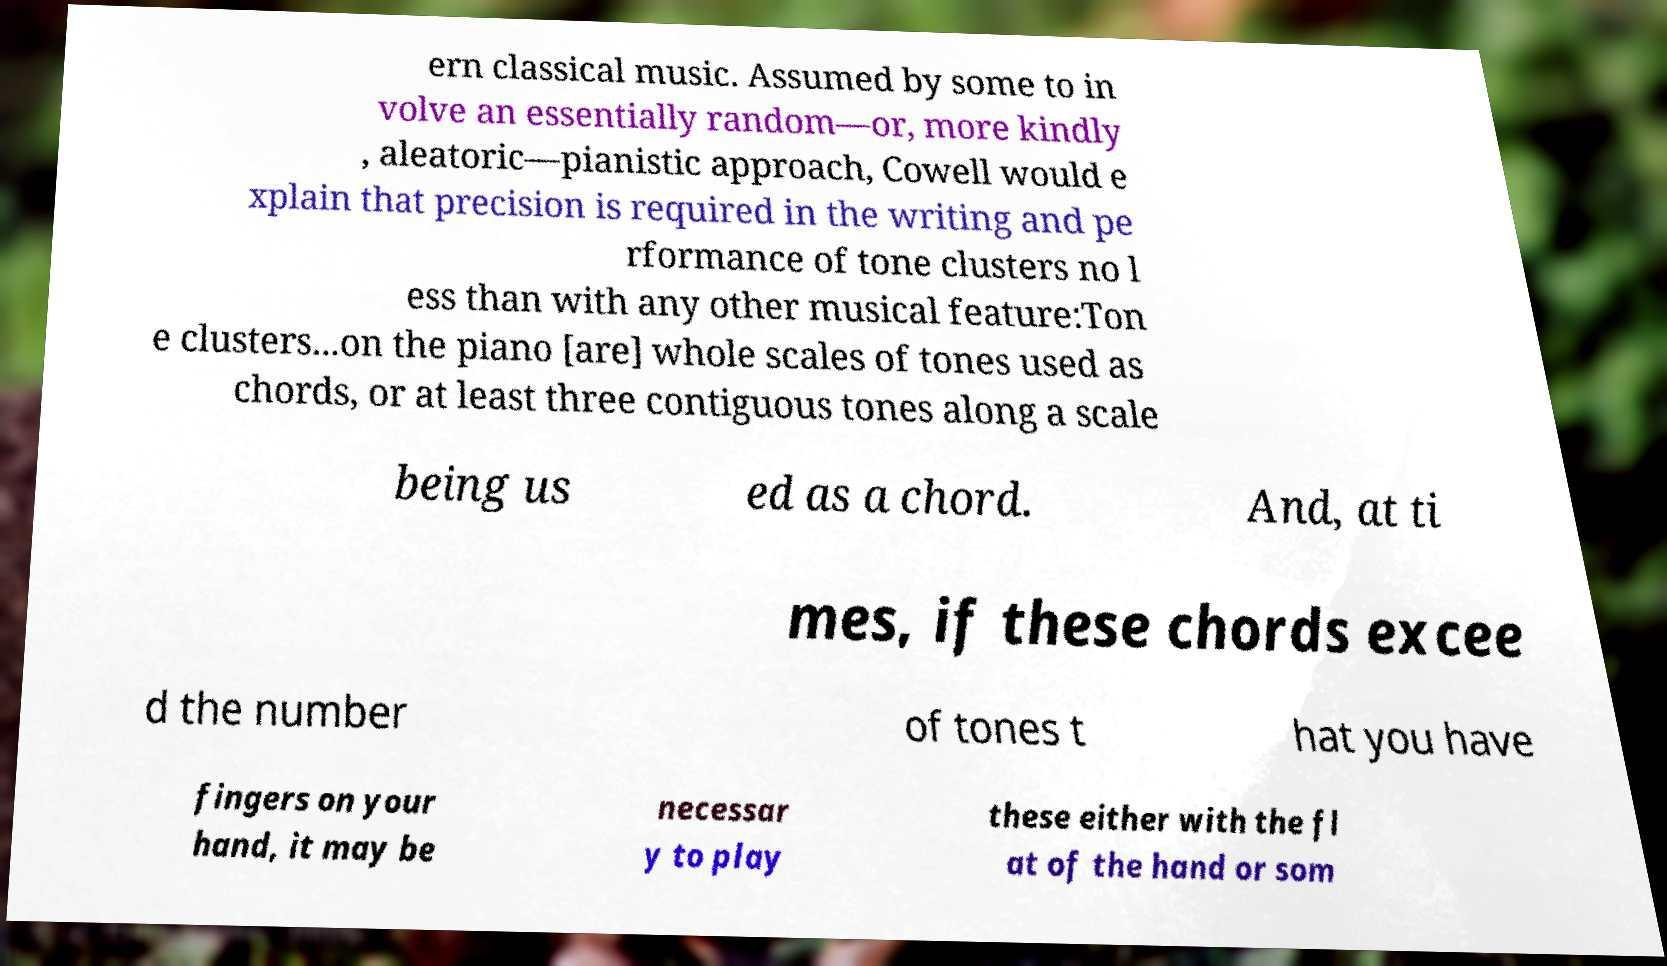For documentation purposes, I need the text within this image transcribed. Could you provide that? ern classical music. Assumed by some to in volve an essentially random—or, more kindly , aleatoric—pianistic approach, Cowell would e xplain that precision is required in the writing and pe rformance of tone clusters no l ess than with any other musical feature:Ton e clusters...on the piano [are] whole scales of tones used as chords, or at least three contiguous tones along a scale being us ed as a chord. And, at ti mes, if these chords excee d the number of tones t hat you have fingers on your hand, it may be necessar y to play these either with the fl at of the hand or som 